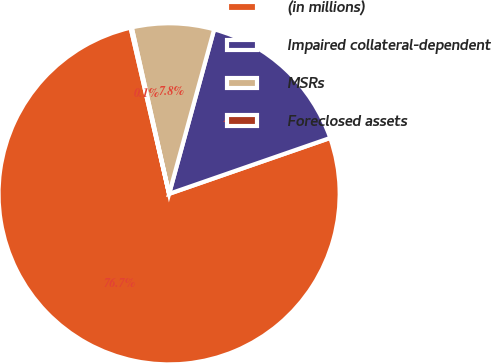Convert chart. <chart><loc_0><loc_0><loc_500><loc_500><pie_chart><fcel>(in millions)<fcel>Impaired collateral-dependent<fcel>MSRs<fcel>Foreclosed assets<nl><fcel>76.69%<fcel>15.43%<fcel>7.77%<fcel>0.11%<nl></chart> 